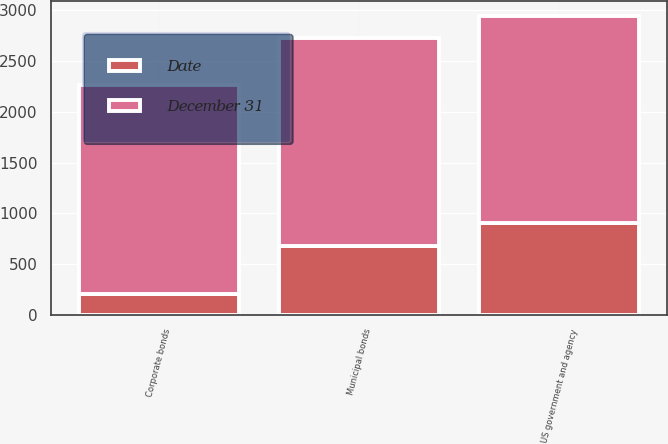<chart> <loc_0><loc_0><loc_500><loc_500><stacked_bar_chart><ecel><fcel>Municipal bonds<fcel>US government and agency<fcel>Corporate bonds<nl><fcel>December 31<fcel>2051<fcel>2044<fcel>2054<nl><fcel>Date<fcel>675<fcel>902<fcel>208<nl></chart> 